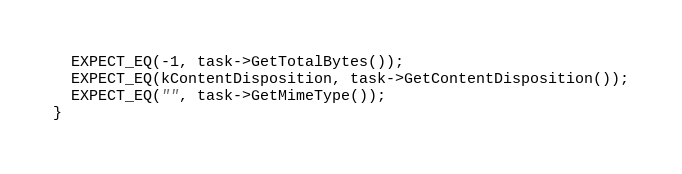<code> <loc_0><loc_0><loc_500><loc_500><_ObjectiveC_>  EXPECT_EQ(-1, task->GetTotalBytes());
  EXPECT_EQ(kContentDisposition, task->GetContentDisposition());
  EXPECT_EQ("", task->GetMimeType());
}
</code> 